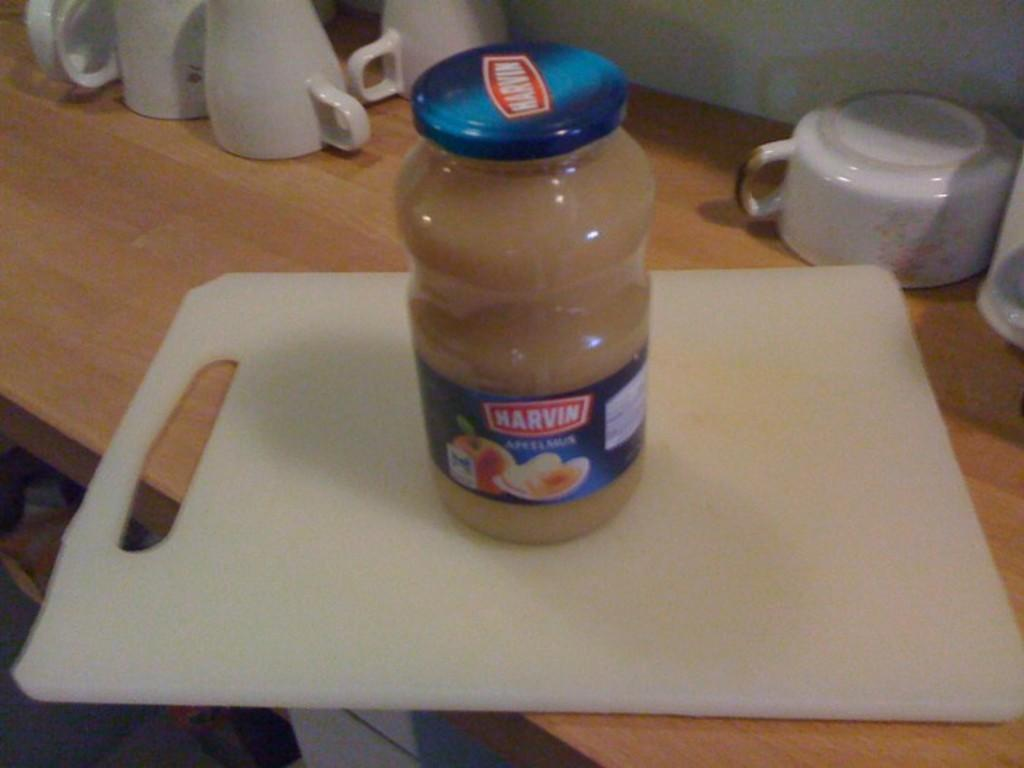<image>
Present a compact description of the photo's key features. A Marvin brand jar is on a cutting board. 